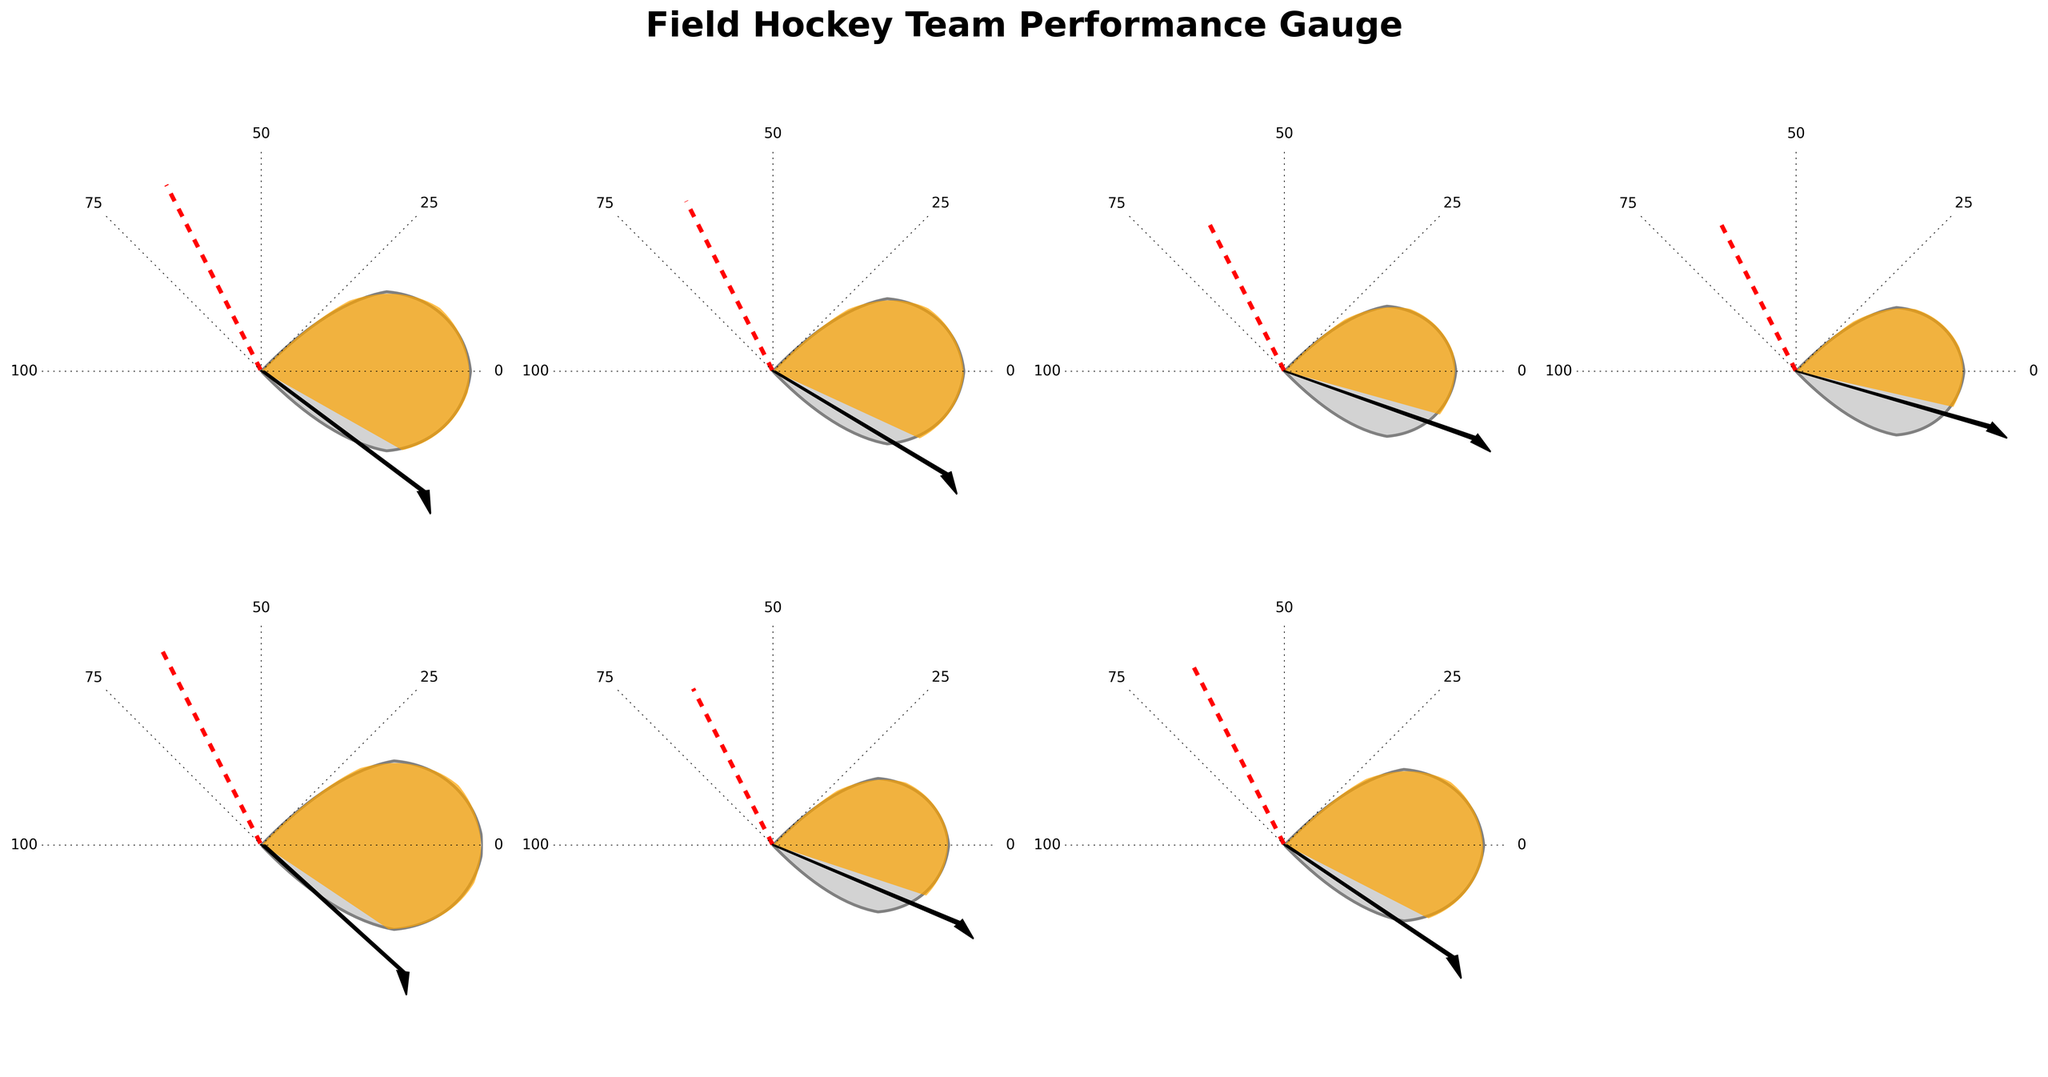What's the title of the figure? The title of the figure is displayed at the top, showing the overall context of the visual information.
Answer: "Field Hockey Team Performance Gauge" How many teams are displayed in the figure? By counting the number of individual gauge charts, we can determine the number of teams displayed.
Answer: 7 Which team has the highest performance rating? By looking at the angles of the colored arcs, we see that the Ottawa Outlaws have the longest arc, reflecting the highest rating.
Answer: Ottawa Outlaws Which teams have performance ratings above the league average? We compare each team's rating against the league average line. Teams with their needle past the league average point are above average.
Answer: Toronto Field Hockey Club, Ottawa Outlaws, Winnipeg Warriors, Vancouver Falcons What's the performance rating difference between the Toronto Field Hockey Club and the Calgary Chinooks? Toronto's rating: 72, Calgary's rating: 61. Subtract Calgary's rating from Toronto's rating.
Answer: 11 Which team is performing closest to the league average? By visually comparing the team ratings to the league average line, the team whose needle is closest to the red dashed line can be identified.
Answer: Montreal Mavericks What's the average performance rating of all teams? Sum all ratings (72+68+61+59+76+63+70) and divide by the number of teams (7).
Answer: 67 How does the Toronto Field Hockey Club's performance compare to the league average? The Toronto Field Hockey Club has a performance rating of 72, which is higher than the league average of 65, indicated by the needle position on the gauge.
Answer: Higher Which team has the lowest performance rating? By identifying the shortest arc in the gauges, we find that the Edmonton Elks have the lowest rating.
Answer: Edmonton Elks By how much does the performance rating of the Winnipeg Warriors exceed that of the Edmonton Elks? Winnipeg's rating: 70, Edmonton's rating: 59. Subtract Edmonton's rating from Winnipeg's rating.
Answer: 11 